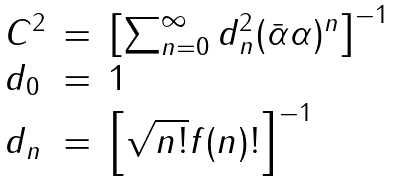<formula> <loc_0><loc_0><loc_500><loc_500>\begin{array} { l c l } C ^ { 2 } & = & \left [ \sum _ { n = 0 } ^ { \infty } d _ { n } ^ { 2 } ( \bar { \alpha } \alpha ) ^ { n } \right ] ^ { - 1 } \\ d _ { 0 } & = & 1 \\ d _ { n } & = & \left [ \sqrt { n ! } f ( n ) ! \right ] ^ { - 1 } \end{array}</formula> 